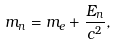Convert formula to latex. <formula><loc_0><loc_0><loc_500><loc_500>m _ { n } = m _ { e } + \frac { E _ { n } } { c ^ { 2 } } ,</formula> 